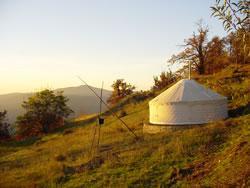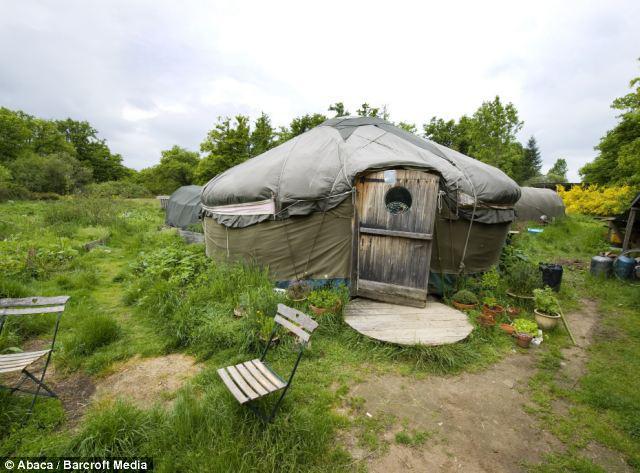The first image is the image on the left, the second image is the image on the right. Evaluate the accuracy of this statement regarding the images: "there is exactly one person in the image on the right.". Is it true? Answer yes or no. No. 